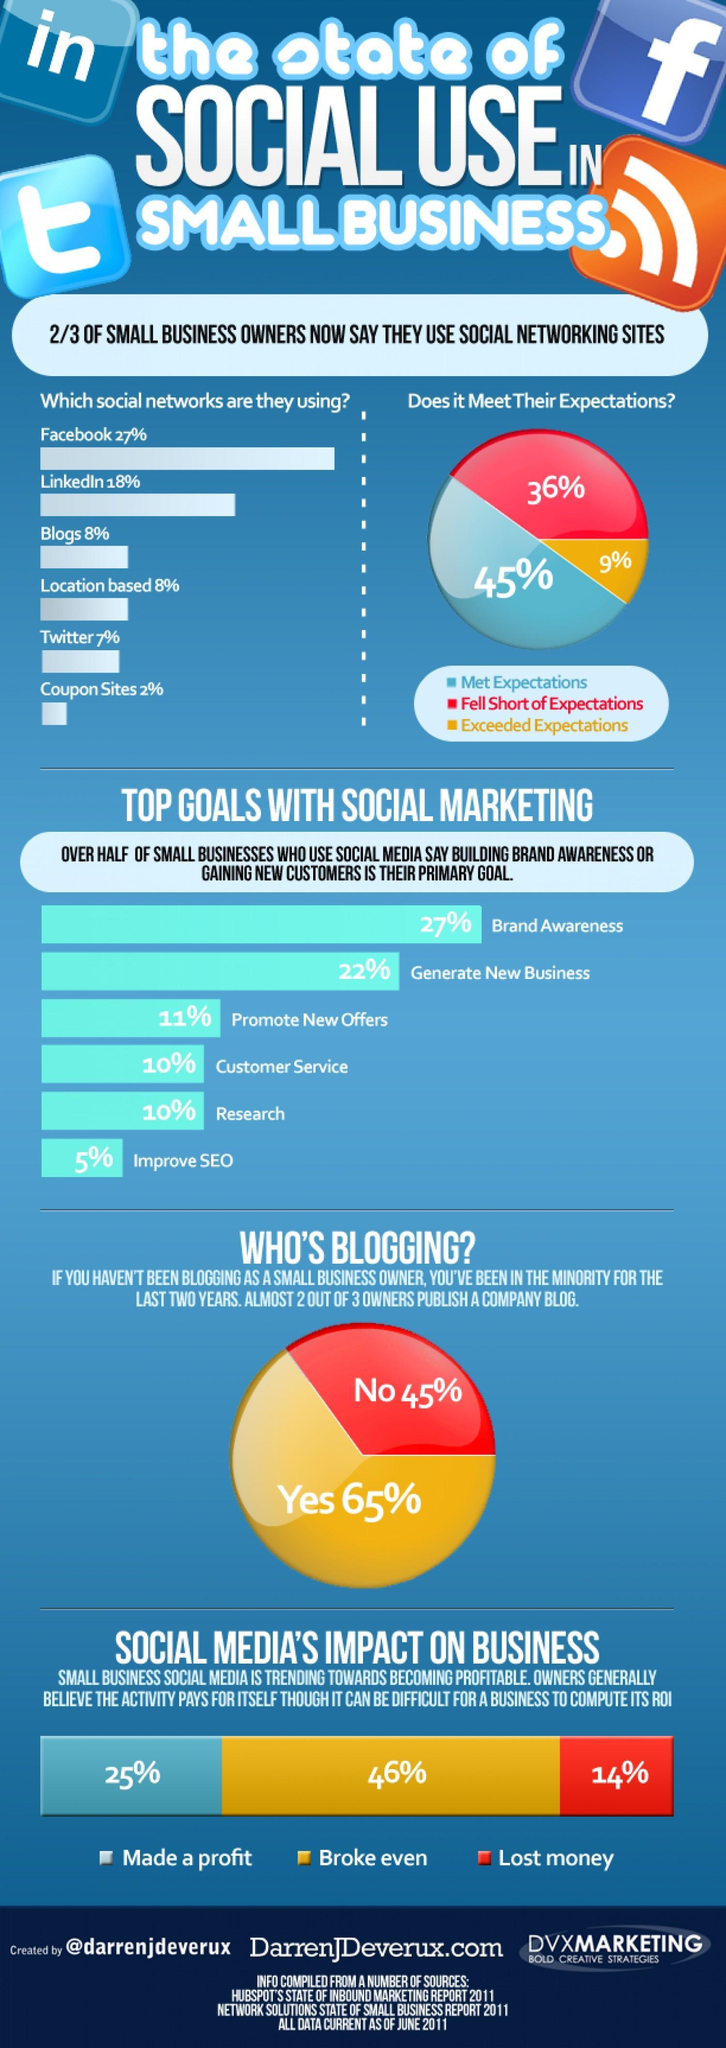Facebook and linkedin together account for what percentage of social networks used by small business owners?
Answer the question with a short phrase. 45 What percentage of business owners opine that social networking sites have exceeded their expectations? 9% What percentage of "small" businessmen have made a profit through social media? 25% What is the second top goal with social marketing? generate new business 